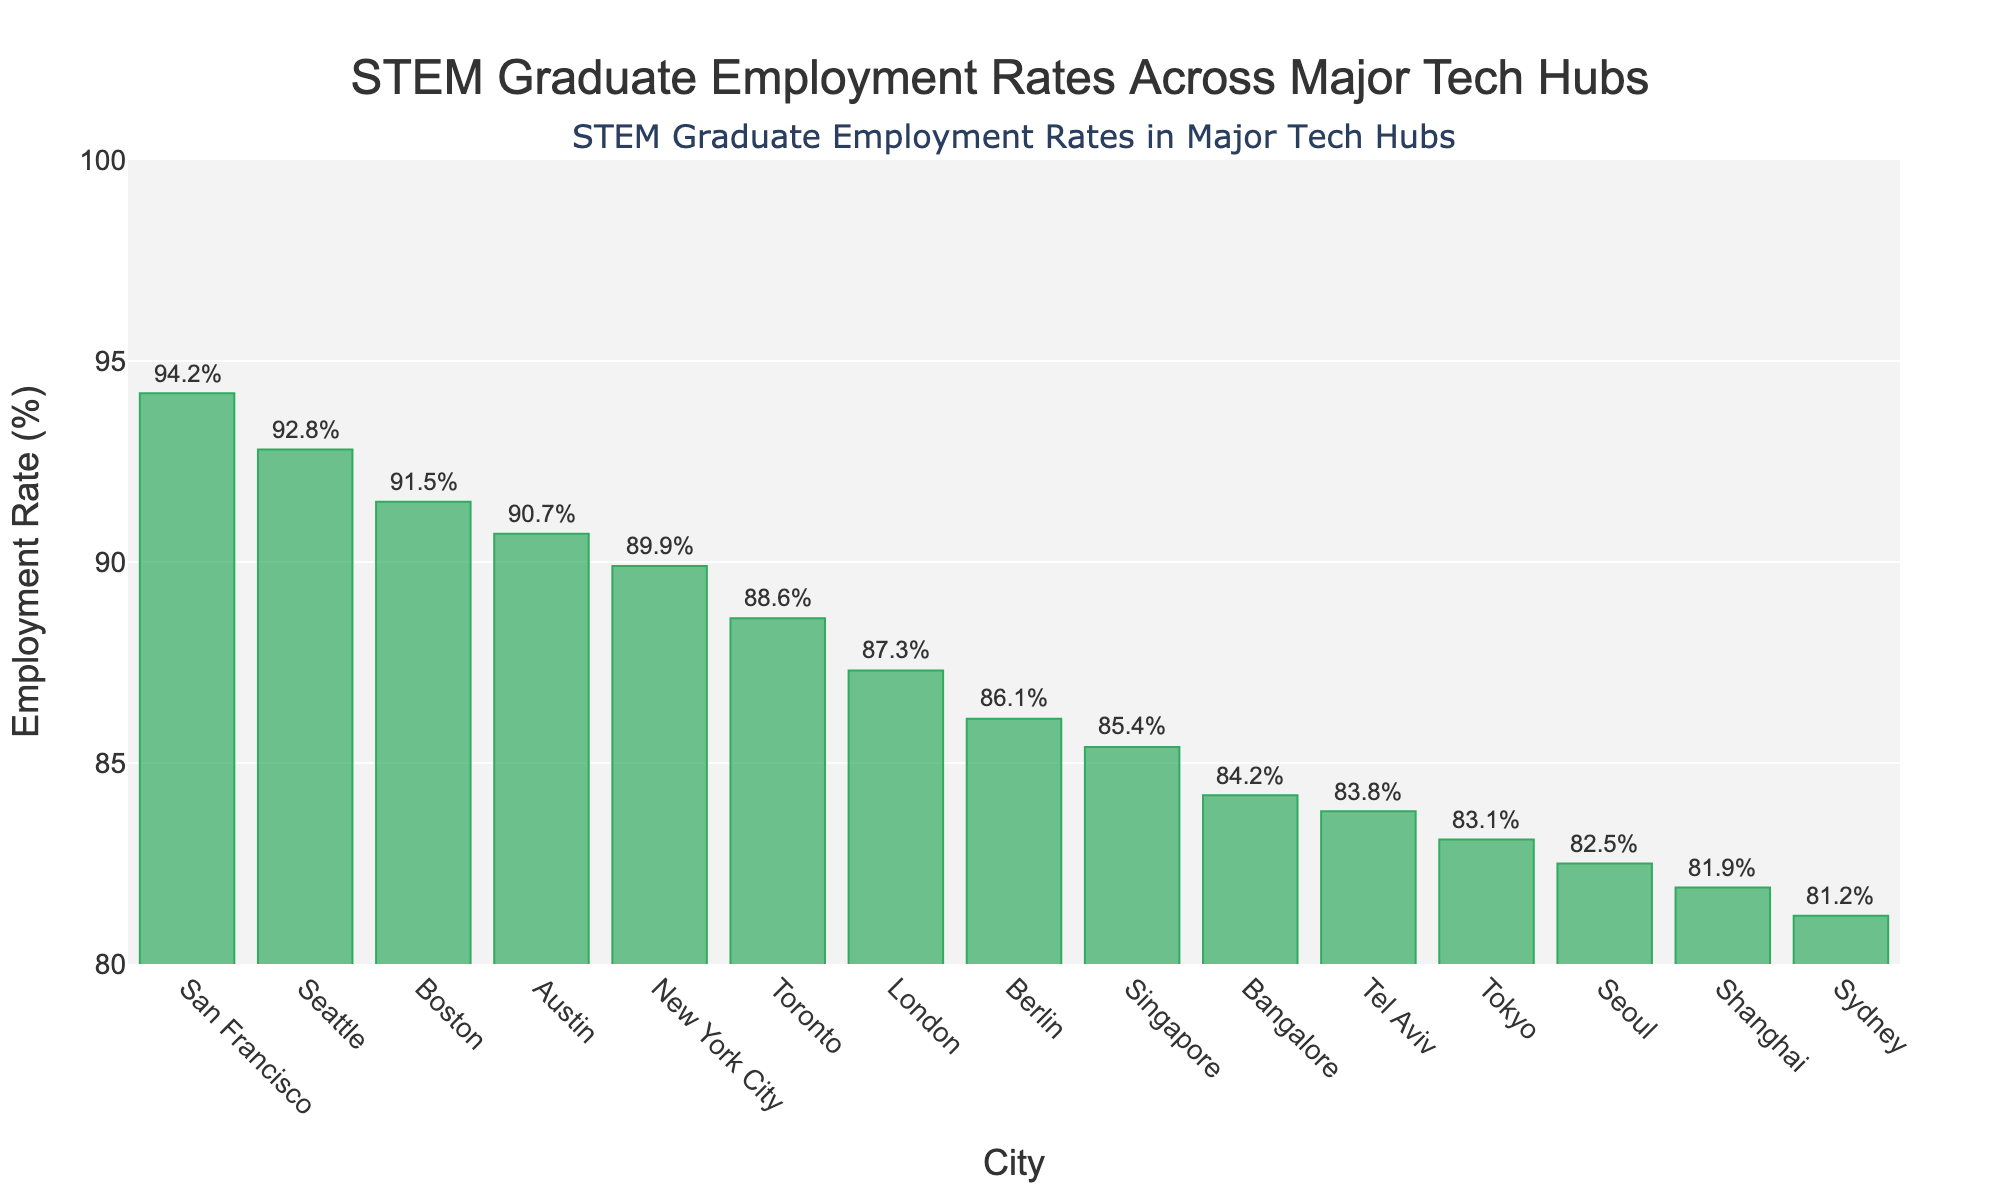What city has the highest STEM graduate employment rate? According to the figure, the tallest bar corresponds to San Francisco with an employment rate of 94.2%.
Answer: San Francisco Which city has the lowest STEM graduate employment rate? By examining the shortest bar, it is seen that Sydney has the lowest employment rate at 81.2%.
Answer: Sydney What is the difference in STEM graduate employment rates between Seattle and Toronto? Seattle's rate is 92.8% and Toronto's is 88.6%. The difference is 92.8% - 88.6% = 4.2%.
Answer: 4.2% Between Austin and New York City, which has a higher employment rate and by how much? Austin’s rate is 90.7% and New York City's rate is 89.9%. The difference is 90.7% - 89.9% = 0.8%.
Answer: Austin, 0.8% What is the average STEM graduate employment rate of Tokyo, Seoul, and Shanghai? Tokyo has 83.1%, Seoul has 82.5%, and Shanghai has 81.9%. The average is (83.1% + 82.5% + 81.9%) / 3 = 82.5%.
Answer: 82.5% How does Berlin's employment rate compare to Tel Aviv's? Berlin has an employment rate of 86.1%, while Tel Aviv’s rate is 83.8%. Berlin's rate is higher.
Answer: Berlin, higher Which city has a higher STEM graduate employment rate: London or Singapore? London has an employment rate of 87.3%, while Singapore has 85.4%. London’s rate is higher.
Answer: London What is the total range of STEM graduate employment rates in the figure? The highest rate is 94.2% (San Francisco) and the lowest is 81.2% (Sydney). Range = 94.2% - 81.2% = 13%.
Answer: 13% Rank Boston, Austin, and Seattle in increasing order of STEM graduate employment rates. Boston has 91.5%, Austin has 90.7%, and Seattle has 92.8%. The order is Austin (90.7%), Boston (91.5%), Seattle (92.8%).
Answer: Austin, Boston, Seattle What is the combined STEM graduate employment rate for London and New York City? London's rate is 87.3% and New York City's rate is 89.9%. Combined rate = 87.3% + 89.9% = 177.2%.
Answer: 177.2% 